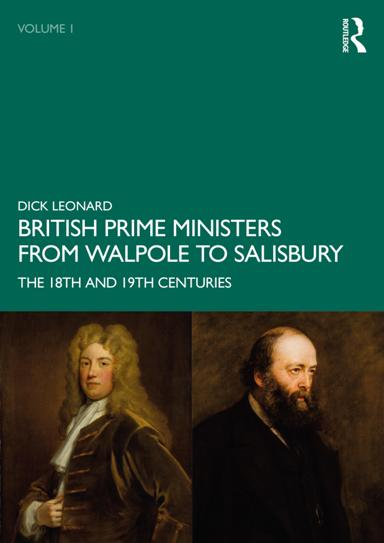How does the book shed light on the political evolution during these centuries? The book provides detailed narratives on how political structures, public policies, and leadership styles evolved during the 18th and 19th centuries in Britain, offering insights into the transition from absolute monarchies to more democratic parliamentary systems. Can you give an example of a particular reform or policy discussed in the book? One notable reform discussed is the Reform Act of 1832, led by Prime Minister Charles Grey, 2nd Earl Grey. This act was crucial in reforming electoral systems in England and Wales, reducing the power of landowners and broadening the electoral base. 